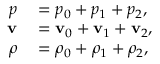Convert formula to latex. <formula><loc_0><loc_0><loc_500><loc_500>\begin{array} { r l } { p } & = p _ { 0 } + p _ { 1 } + p _ { 2 } , } \\ { v } & = v _ { 0 } + v _ { 1 } + v _ { 2 } , } \\ { \rho } & = \rho _ { 0 } + \rho _ { 1 } + \rho _ { 2 } , } \end{array}</formula> 